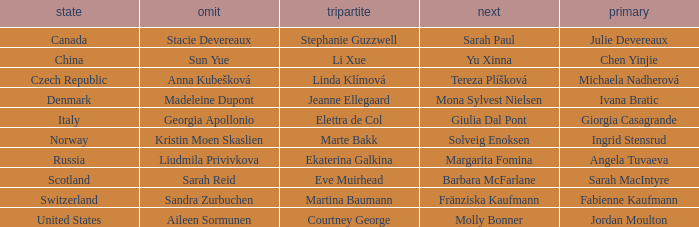What is the second that has jordan moulton as the lead? Molly Bonner. 